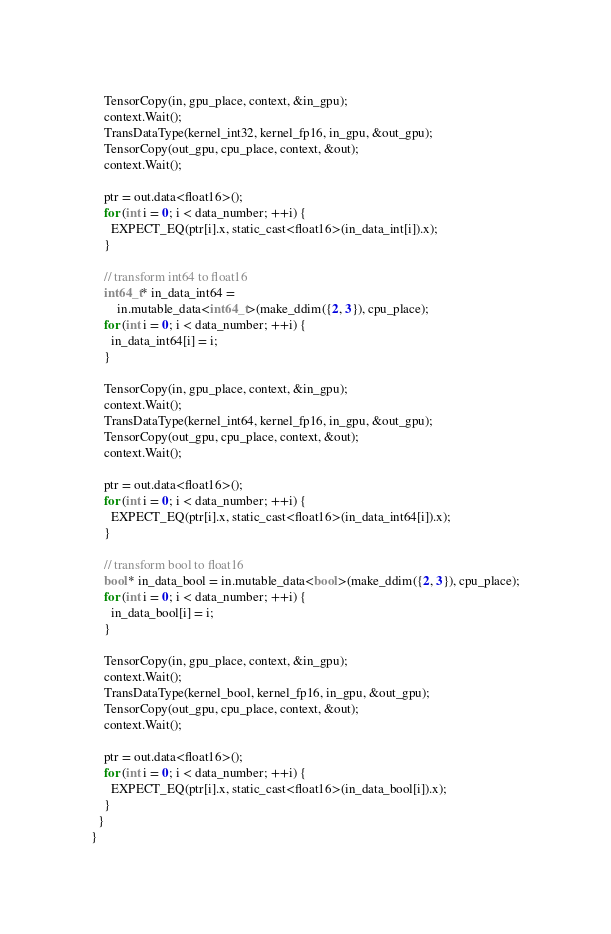Convert code to text. <code><loc_0><loc_0><loc_500><loc_500><_Cuda_>
    TensorCopy(in, gpu_place, context, &in_gpu);
    context.Wait();
    TransDataType(kernel_int32, kernel_fp16, in_gpu, &out_gpu);
    TensorCopy(out_gpu, cpu_place, context, &out);
    context.Wait();

    ptr = out.data<float16>();
    for (int i = 0; i < data_number; ++i) {
      EXPECT_EQ(ptr[i].x, static_cast<float16>(in_data_int[i]).x);
    }

    // transform int64 to float16
    int64_t* in_data_int64 =
        in.mutable_data<int64_t>(make_ddim({2, 3}), cpu_place);
    for (int i = 0; i < data_number; ++i) {
      in_data_int64[i] = i;
    }

    TensorCopy(in, gpu_place, context, &in_gpu);
    context.Wait();
    TransDataType(kernel_int64, kernel_fp16, in_gpu, &out_gpu);
    TensorCopy(out_gpu, cpu_place, context, &out);
    context.Wait();

    ptr = out.data<float16>();
    for (int i = 0; i < data_number; ++i) {
      EXPECT_EQ(ptr[i].x, static_cast<float16>(in_data_int64[i]).x);
    }

    // transform bool to float16
    bool* in_data_bool = in.mutable_data<bool>(make_ddim({2, 3}), cpu_place);
    for (int i = 0; i < data_number; ++i) {
      in_data_bool[i] = i;
    }

    TensorCopy(in, gpu_place, context, &in_gpu);
    context.Wait();
    TransDataType(kernel_bool, kernel_fp16, in_gpu, &out_gpu);
    TensorCopy(out_gpu, cpu_place, context, &out);
    context.Wait();

    ptr = out.data<float16>();
    for (int i = 0; i < data_number; ++i) {
      EXPECT_EQ(ptr[i].x, static_cast<float16>(in_data_bool[i]).x);
    }
  }
}
</code> 